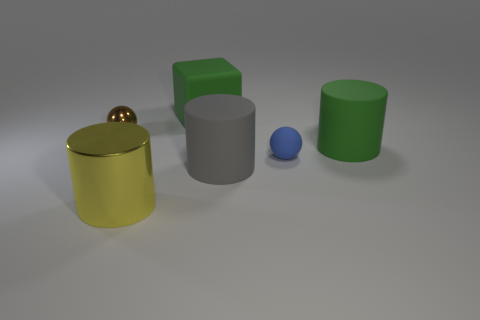Subtract all blue cylinders. Subtract all gray balls. How many cylinders are left? 3 Add 2 purple objects. How many objects exist? 8 Subtract all cubes. How many objects are left? 5 Subtract 0 blue cylinders. How many objects are left? 6 Subtract all shiny spheres. Subtract all large things. How many objects are left? 1 Add 4 matte blocks. How many matte blocks are left? 5 Add 3 big balls. How many big balls exist? 3 